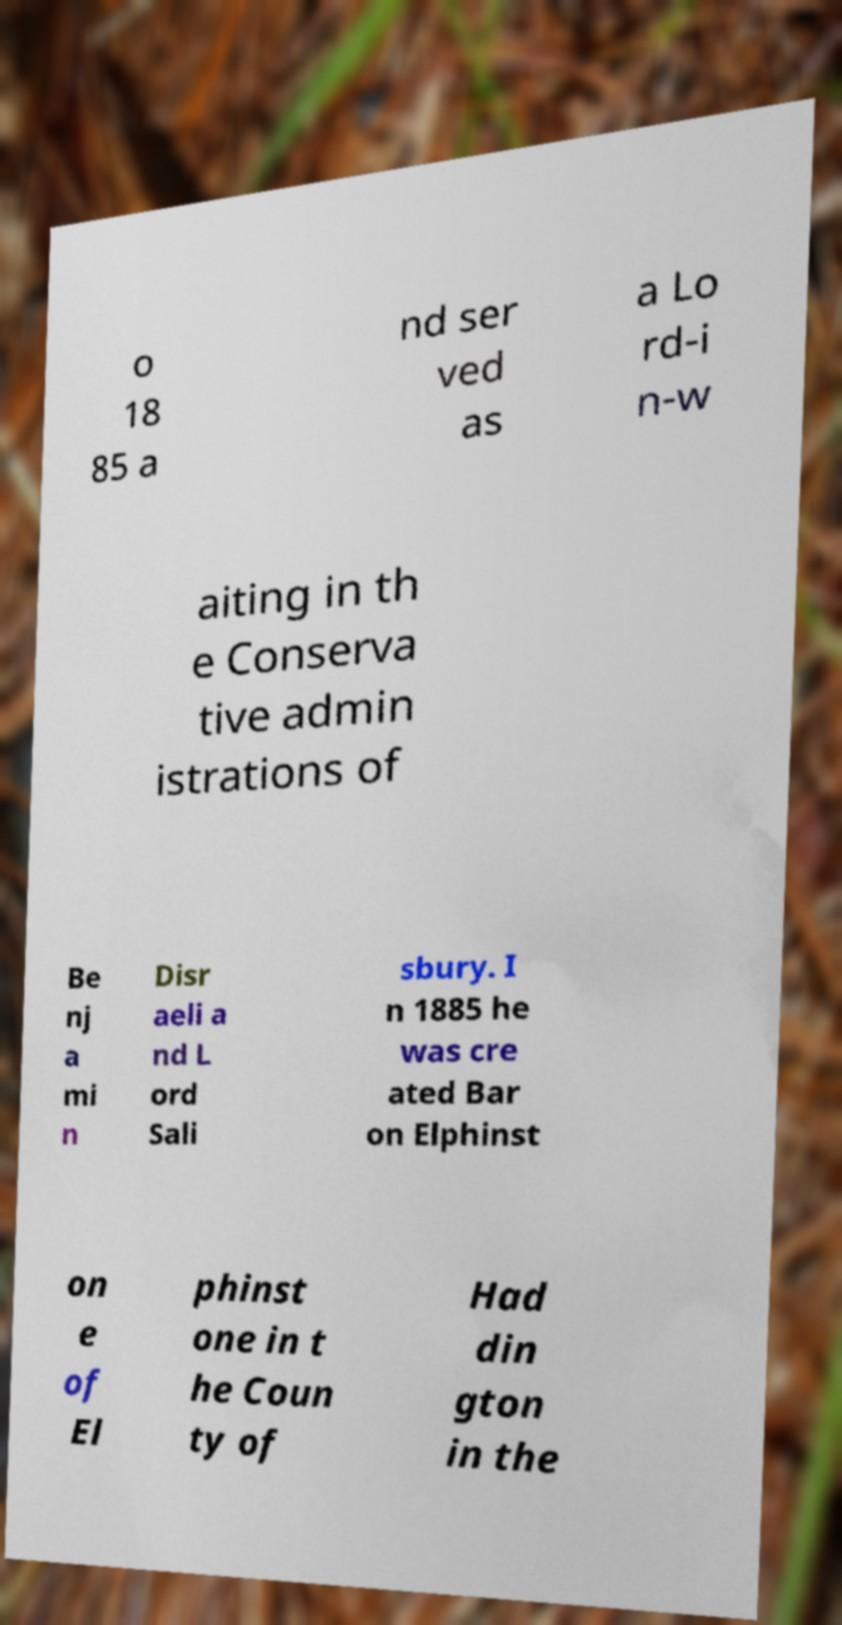For documentation purposes, I need the text within this image transcribed. Could you provide that? o 18 85 a nd ser ved as a Lo rd-i n-w aiting in th e Conserva tive admin istrations of Be nj a mi n Disr aeli a nd L ord Sali sbury. I n 1885 he was cre ated Bar on Elphinst on e of El phinst one in t he Coun ty of Had din gton in the 